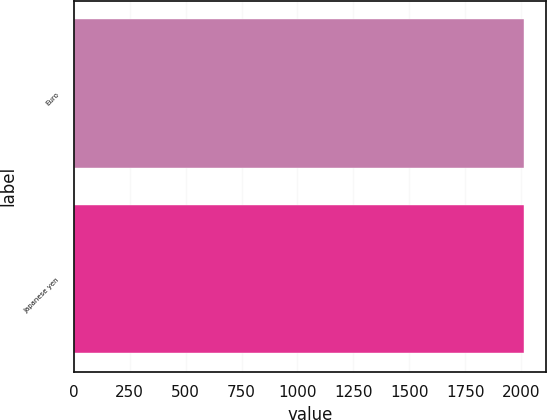Convert chart to OTSL. <chart><loc_0><loc_0><loc_500><loc_500><bar_chart><fcel>Euro<fcel>Japanese yen<nl><fcel>2011<fcel>2011.1<nl></chart> 